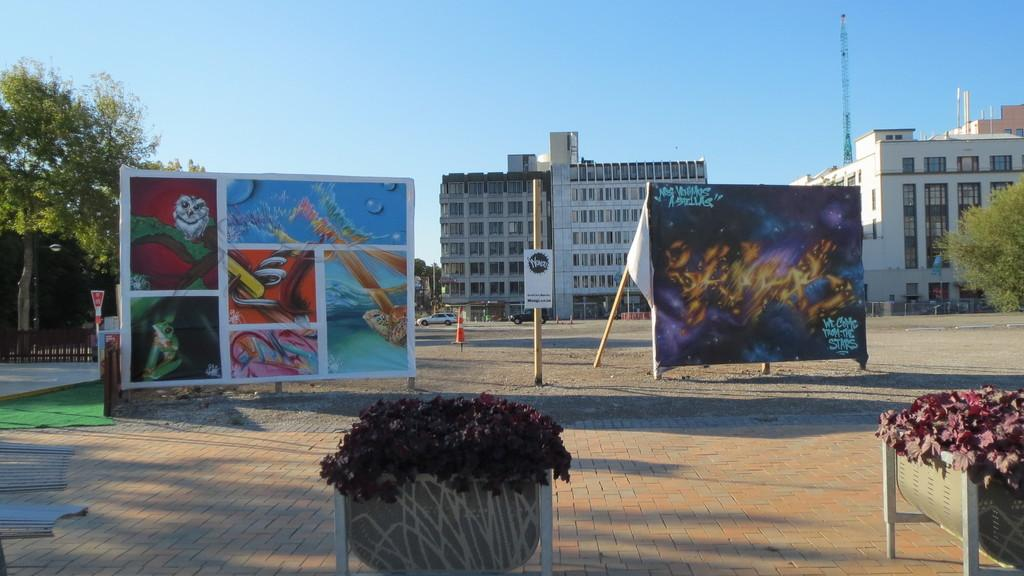What can be seen hanging or displayed in the image? There are banners in the image. Where are the banners located? The banners are on the ground. What type of natural elements are present in the area? There are trees in the area. What can be seen in the distance in the image? There are buildings visible in the background. What type of frame is used to display the songs in the image? There are no songs or frames present in the image; it features banners on the ground with trees and buildings in the background. 